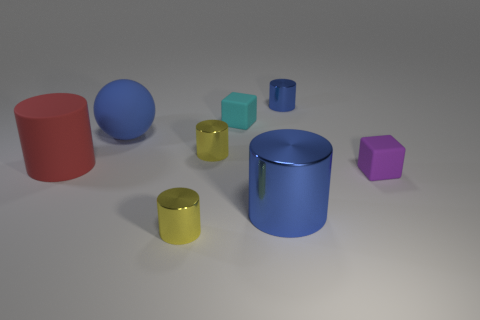How many yellow cylinders must be subtracted to get 1 yellow cylinders? 1 Subtract all metal cylinders. How many cylinders are left? 1 Subtract all balls. How many objects are left? 7 Add 7 cyan blocks. How many cyan blocks exist? 8 Add 1 tiny blocks. How many objects exist? 9 Subtract all red cylinders. How many cylinders are left? 4 Subtract 0 yellow balls. How many objects are left? 8 Subtract all blue cylinders. Subtract all green cubes. How many cylinders are left? 3 Subtract all cyan balls. How many purple cubes are left? 1 Subtract all rubber spheres. Subtract all yellow objects. How many objects are left? 5 